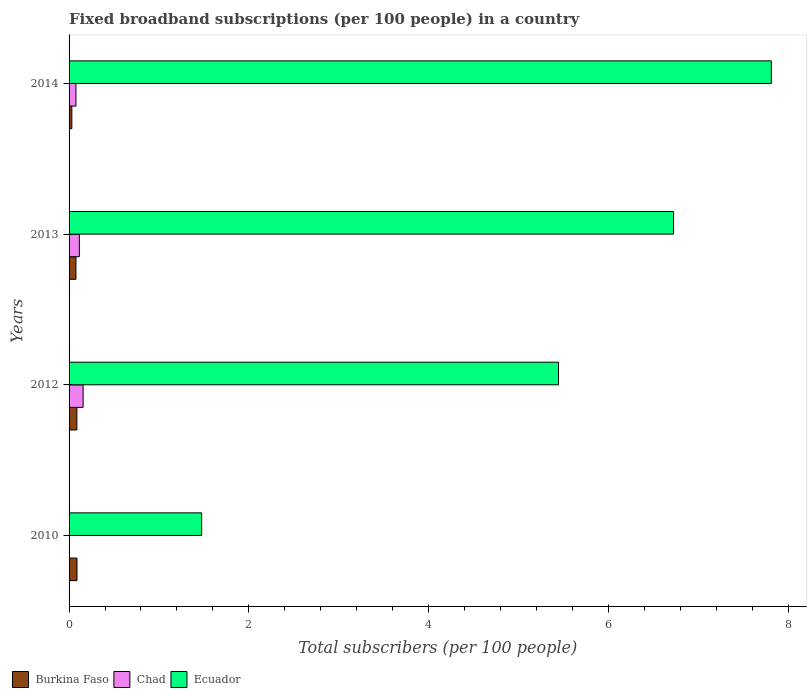How many different coloured bars are there?
Provide a succinct answer. 3. Are the number of bars per tick equal to the number of legend labels?
Your answer should be compact. Yes. Are the number of bars on each tick of the Y-axis equal?
Provide a short and direct response. Yes. How many bars are there on the 4th tick from the top?
Make the answer very short. 3. How many bars are there on the 4th tick from the bottom?
Make the answer very short. 3. What is the label of the 2nd group of bars from the top?
Provide a short and direct response. 2013. In how many cases, is the number of bars for a given year not equal to the number of legend labels?
Your response must be concise. 0. What is the number of broadband subscriptions in Ecuador in 2010?
Make the answer very short. 1.48. Across all years, what is the maximum number of broadband subscriptions in Chad?
Your answer should be very brief. 0.16. Across all years, what is the minimum number of broadband subscriptions in Chad?
Keep it short and to the point. 0. In which year was the number of broadband subscriptions in Chad maximum?
Keep it short and to the point. 2012. What is the total number of broadband subscriptions in Ecuador in the graph?
Keep it short and to the point. 21.46. What is the difference between the number of broadband subscriptions in Ecuador in 2013 and that in 2014?
Give a very brief answer. -1.09. What is the difference between the number of broadband subscriptions in Ecuador in 2014 and the number of broadband subscriptions in Chad in 2012?
Make the answer very short. 7.66. What is the average number of broadband subscriptions in Chad per year?
Provide a short and direct response. 0.09. In the year 2010, what is the difference between the number of broadband subscriptions in Burkina Faso and number of broadband subscriptions in Ecuador?
Offer a very short reply. -1.39. What is the ratio of the number of broadband subscriptions in Ecuador in 2010 to that in 2013?
Keep it short and to the point. 0.22. What is the difference between the highest and the second highest number of broadband subscriptions in Chad?
Offer a terse response. 0.04. What is the difference between the highest and the lowest number of broadband subscriptions in Burkina Faso?
Make the answer very short. 0.06. What does the 3rd bar from the top in 2013 represents?
Offer a terse response. Burkina Faso. What does the 1st bar from the bottom in 2013 represents?
Ensure brevity in your answer.  Burkina Faso. How many bars are there?
Your answer should be compact. 12. Are all the bars in the graph horizontal?
Offer a very short reply. Yes. What is the difference between two consecutive major ticks on the X-axis?
Your answer should be very brief. 2. Are the values on the major ticks of X-axis written in scientific E-notation?
Provide a short and direct response. No. Does the graph contain grids?
Your response must be concise. No. Where does the legend appear in the graph?
Provide a succinct answer. Bottom left. What is the title of the graph?
Give a very brief answer. Fixed broadband subscriptions (per 100 people) in a country. What is the label or title of the X-axis?
Provide a short and direct response. Total subscribers (per 100 people). What is the Total subscribers (per 100 people) in Burkina Faso in 2010?
Your response must be concise. 0.09. What is the Total subscribers (per 100 people) in Chad in 2010?
Give a very brief answer. 0. What is the Total subscribers (per 100 people) in Ecuador in 2010?
Your response must be concise. 1.48. What is the Total subscribers (per 100 people) in Burkina Faso in 2012?
Offer a very short reply. 0.09. What is the Total subscribers (per 100 people) in Chad in 2012?
Keep it short and to the point. 0.16. What is the Total subscribers (per 100 people) of Ecuador in 2012?
Keep it short and to the point. 5.45. What is the Total subscribers (per 100 people) of Burkina Faso in 2013?
Give a very brief answer. 0.08. What is the Total subscribers (per 100 people) of Chad in 2013?
Offer a very short reply. 0.11. What is the Total subscribers (per 100 people) of Ecuador in 2013?
Your response must be concise. 6.73. What is the Total subscribers (per 100 people) in Burkina Faso in 2014?
Ensure brevity in your answer.  0.03. What is the Total subscribers (per 100 people) of Chad in 2014?
Your response must be concise. 0.08. What is the Total subscribers (per 100 people) of Ecuador in 2014?
Your answer should be very brief. 7.81. Across all years, what is the maximum Total subscribers (per 100 people) of Burkina Faso?
Offer a very short reply. 0.09. Across all years, what is the maximum Total subscribers (per 100 people) in Chad?
Keep it short and to the point. 0.16. Across all years, what is the maximum Total subscribers (per 100 people) of Ecuador?
Your response must be concise. 7.81. Across all years, what is the minimum Total subscribers (per 100 people) of Burkina Faso?
Offer a terse response. 0.03. Across all years, what is the minimum Total subscribers (per 100 people) of Chad?
Your answer should be very brief. 0. Across all years, what is the minimum Total subscribers (per 100 people) in Ecuador?
Ensure brevity in your answer.  1.48. What is the total Total subscribers (per 100 people) in Burkina Faso in the graph?
Make the answer very short. 0.28. What is the total Total subscribers (per 100 people) of Chad in the graph?
Ensure brevity in your answer.  0.35. What is the total Total subscribers (per 100 people) in Ecuador in the graph?
Keep it short and to the point. 21.46. What is the difference between the Total subscribers (per 100 people) of Burkina Faso in 2010 and that in 2012?
Offer a terse response. 0. What is the difference between the Total subscribers (per 100 people) in Chad in 2010 and that in 2012?
Offer a very short reply. -0.15. What is the difference between the Total subscribers (per 100 people) in Ecuador in 2010 and that in 2012?
Offer a terse response. -3.97. What is the difference between the Total subscribers (per 100 people) in Burkina Faso in 2010 and that in 2013?
Offer a very short reply. 0.01. What is the difference between the Total subscribers (per 100 people) of Chad in 2010 and that in 2013?
Your answer should be compact. -0.11. What is the difference between the Total subscribers (per 100 people) in Ecuador in 2010 and that in 2013?
Your answer should be very brief. -5.25. What is the difference between the Total subscribers (per 100 people) in Burkina Faso in 2010 and that in 2014?
Offer a terse response. 0.06. What is the difference between the Total subscribers (per 100 people) of Chad in 2010 and that in 2014?
Give a very brief answer. -0.07. What is the difference between the Total subscribers (per 100 people) of Ecuador in 2010 and that in 2014?
Offer a very short reply. -6.34. What is the difference between the Total subscribers (per 100 people) in Burkina Faso in 2012 and that in 2013?
Offer a very short reply. 0.01. What is the difference between the Total subscribers (per 100 people) in Chad in 2012 and that in 2013?
Your answer should be very brief. 0.04. What is the difference between the Total subscribers (per 100 people) in Ecuador in 2012 and that in 2013?
Make the answer very short. -1.28. What is the difference between the Total subscribers (per 100 people) of Burkina Faso in 2012 and that in 2014?
Your response must be concise. 0.06. What is the difference between the Total subscribers (per 100 people) of Chad in 2012 and that in 2014?
Ensure brevity in your answer.  0.08. What is the difference between the Total subscribers (per 100 people) in Ecuador in 2012 and that in 2014?
Your response must be concise. -2.37. What is the difference between the Total subscribers (per 100 people) in Burkina Faso in 2013 and that in 2014?
Offer a very short reply. 0.05. What is the difference between the Total subscribers (per 100 people) in Chad in 2013 and that in 2014?
Provide a succinct answer. 0.04. What is the difference between the Total subscribers (per 100 people) of Ecuador in 2013 and that in 2014?
Offer a very short reply. -1.09. What is the difference between the Total subscribers (per 100 people) of Burkina Faso in 2010 and the Total subscribers (per 100 people) of Chad in 2012?
Make the answer very short. -0.07. What is the difference between the Total subscribers (per 100 people) of Burkina Faso in 2010 and the Total subscribers (per 100 people) of Ecuador in 2012?
Give a very brief answer. -5.36. What is the difference between the Total subscribers (per 100 people) in Chad in 2010 and the Total subscribers (per 100 people) in Ecuador in 2012?
Make the answer very short. -5.44. What is the difference between the Total subscribers (per 100 people) in Burkina Faso in 2010 and the Total subscribers (per 100 people) in Chad in 2013?
Make the answer very short. -0.03. What is the difference between the Total subscribers (per 100 people) of Burkina Faso in 2010 and the Total subscribers (per 100 people) of Ecuador in 2013?
Offer a very short reply. -6.64. What is the difference between the Total subscribers (per 100 people) of Chad in 2010 and the Total subscribers (per 100 people) of Ecuador in 2013?
Make the answer very short. -6.72. What is the difference between the Total subscribers (per 100 people) of Burkina Faso in 2010 and the Total subscribers (per 100 people) of Chad in 2014?
Provide a succinct answer. 0.01. What is the difference between the Total subscribers (per 100 people) of Burkina Faso in 2010 and the Total subscribers (per 100 people) of Ecuador in 2014?
Your response must be concise. -7.73. What is the difference between the Total subscribers (per 100 people) in Chad in 2010 and the Total subscribers (per 100 people) in Ecuador in 2014?
Give a very brief answer. -7.81. What is the difference between the Total subscribers (per 100 people) in Burkina Faso in 2012 and the Total subscribers (per 100 people) in Chad in 2013?
Offer a very short reply. -0.03. What is the difference between the Total subscribers (per 100 people) in Burkina Faso in 2012 and the Total subscribers (per 100 people) in Ecuador in 2013?
Your response must be concise. -6.64. What is the difference between the Total subscribers (per 100 people) in Chad in 2012 and the Total subscribers (per 100 people) in Ecuador in 2013?
Keep it short and to the point. -6.57. What is the difference between the Total subscribers (per 100 people) in Burkina Faso in 2012 and the Total subscribers (per 100 people) in Chad in 2014?
Ensure brevity in your answer.  0.01. What is the difference between the Total subscribers (per 100 people) of Burkina Faso in 2012 and the Total subscribers (per 100 people) of Ecuador in 2014?
Your answer should be compact. -7.73. What is the difference between the Total subscribers (per 100 people) in Chad in 2012 and the Total subscribers (per 100 people) in Ecuador in 2014?
Offer a very short reply. -7.66. What is the difference between the Total subscribers (per 100 people) in Burkina Faso in 2013 and the Total subscribers (per 100 people) in Chad in 2014?
Make the answer very short. -0. What is the difference between the Total subscribers (per 100 people) of Burkina Faso in 2013 and the Total subscribers (per 100 people) of Ecuador in 2014?
Offer a very short reply. -7.74. What is the difference between the Total subscribers (per 100 people) in Chad in 2013 and the Total subscribers (per 100 people) in Ecuador in 2014?
Your answer should be very brief. -7.7. What is the average Total subscribers (per 100 people) of Burkina Faso per year?
Provide a short and direct response. 0.07. What is the average Total subscribers (per 100 people) in Chad per year?
Your response must be concise. 0.09. What is the average Total subscribers (per 100 people) of Ecuador per year?
Ensure brevity in your answer.  5.37. In the year 2010, what is the difference between the Total subscribers (per 100 people) in Burkina Faso and Total subscribers (per 100 people) in Chad?
Make the answer very short. 0.09. In the year 2010, what is the difference between the Total subscribers (per 100 people) in Burkina Faso and Total subscribers (per 100 people) in Ecuador?
Give a very brief answer. -1.39. In the year 2010, what is the difference between the Total subscribers (per 100 people) of Chad and Total subscribers (per 100 people) of Ecuador?
Your answer should be very brief. -1.47. In the year 2012, what is the difference between the Total subscribers (per 100 people) in Burkina Faso and Total subscribers (per 100 people) in Chad?
Offer a terse response. -0.07. In the year 2012, what is the difference between the Total subscribers (per 100 people) in Burkina Faso and Total subscribers (per 100 people) in Ecuador?
Offer a very short reply. -5.36. In the year 2012, what is the difference between the Total subscribers (per 100 people) of Chad and Total subscribers (per 100 people) of Ecuador?
Make the answer very short. -5.29. In the year 2013, what is the difference between the Total subscribers (per 100 people) of Burkina Faso and Total subscribers (per 100 people) of Chad?
Provide a succinct answer. -0.04. In the year 2013, what is the difference between the Total subscribers (per 100 people) in Burkina Faso and Total subscribers (per 100 people) in Ecuador?
Your answer should be compact. -6.65. In the year 2013, what is the difference between the Total subscribers (per 100 people) in Chad and Total subscribers (per 100 people) in Ecuador?
Ensure brevity in your answer.  -6.61. In the year 2014, what is the difference between the Total subscribers (per 100 people) of Burkina Faso and Total subscribers (per 100 people) of Chad?
Keep it short and to the point. -0.05. In the year 2014, what is the difference between the Total subscribers (per 100 people) in Burkina Faso and Total subscribers (per 100 people) in Ecuador?
Provide a succinct answer. -7.78. In the year 2014, what is the difference between the Total subscribers (per 100 people) in Chad and Total subscribers (per 100 people) in Ecuador?
Your answer should be very brief. -7.74. What is the ratio of the Total subscribers (per 100 people) in Burkina Faso in 2010 to that in 2012?
Your answer should be very brief. 1.01. What is the ratio of the Total subscribers (per 100 people) in Chad in 2010 to that in 2012?
Keep it short and to the point. 0.02. What is the ratio of the Total subscribers (per 100 people) of Ecuador in 2010 to that in 2012?
Ensure brevity in your answer.  0.27. What is the ratio of the Total subscribers (per 100 people) in Burkina Faso in 2010 to that in 2013?
Offer a very short reply. 1.15. What is the ratio of the Total subscribers (per 100 people) in Chad in 2010 to that in 2013?
Ensure brevity in your answer.  0.02. What is the ratio of the Total subscribers (per 100 people) of Ecuador in 2010 to that in 2013?
Offer a terse response. 0.22. What is the ratio of the Total subscribers (per 100 people) of Burkina Faso in 2010 to that in 2014?
Give a very brief answer. 2.85. What is the ratio of the Total subscribers (per 100 people) in Chad in 2010 to that in 2014?
Provide a short and direct response. 0.04. What is the ratio of the Total subscribers (per 100 people) in Ecuador in 2010 to that in 2014?
Ensure brevity in your answer.  0.19. What is the ratio of the Total subscribers (per 100 people) in Burkina Faso in 2012 to that in 2013?
Keep it short and to the point. 1.14. What is the ratio of the Total subscribers (per 100 people) in Chad in 2012 to that in 2013?
Your response must be concise. 1.36. What is the ratio of the Total subscribers (per 100 people) of Ecuador in 2012 to that in 2013?
Your answer should be compact. 0.81. What is the ratio of the Total subscribers (per 100 people) in Burkina Faso in 2012 to that in 2014?
Offer a very short reply. 2.82. What is the ratio of the Total subscribers (per 100 people) of Chad in 2012 to that in 2014?
Your answer should be compact. 2.04. What is the ratio of the Total subscribers (per 100 people) of Ecuador in 2012 to that in 2014?
Offer a very short reply. 0.7. What is the ratio of the Total subscribers (per 100 people) in Burkina Faso in 2013 to that in 2014?
Give a very brief answer. 2.48. What is the ratio of the Total subscribers (per 100 people) in Chad in 2013 to that in 2014?
Give a very brief answer. 1.49. What is the ratio of the Total subscribers (per 100 people) in Ecuador in 2013 to that in 2014?
Make the answer very short. 0.86. What is the difference between the highest and the second highest Total subscribers (per 100 people) of Burkina Faso?
Ensure brevity in your answer.  0. What is the difference between the highest and the second highest Total subscribers (per 100 people) of Chad?
Make the answer very short. 0.04. What is the difference between the highest and the second highest Total subscribers (per 100 people) of Ecuador?
Make the answer very short. 1.09. What is the difference between the highest and the lowest Total subscribers (per 100 people) of Burkina Faso?
Give a very brief answer. 0.06. What is the difference between the highest and the lowest Total subscribers (per 100 people) of Chad?
Offer a terse response. 0.15. What is the difference between the highest and the lowest Total subscribers (per 100 people) in Ecuador?
Your answer should be very brief. 6.34. 